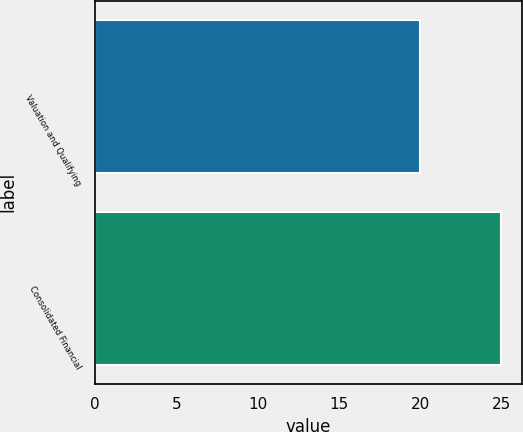<chart> <loc_0><loc_0><loc_500><loc_500><bar_chart><fcel>Valuation and Qualifying<fcel>Consolidated Financial<nl><fcel>20<fcel>25<nl></chart> 